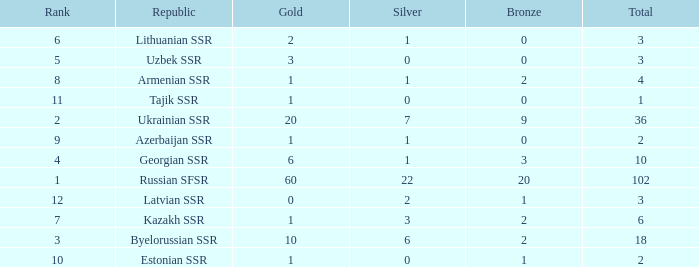What is the highest number of bronzes for teams ranked number 7 with more than 0 silver? 2.0. 